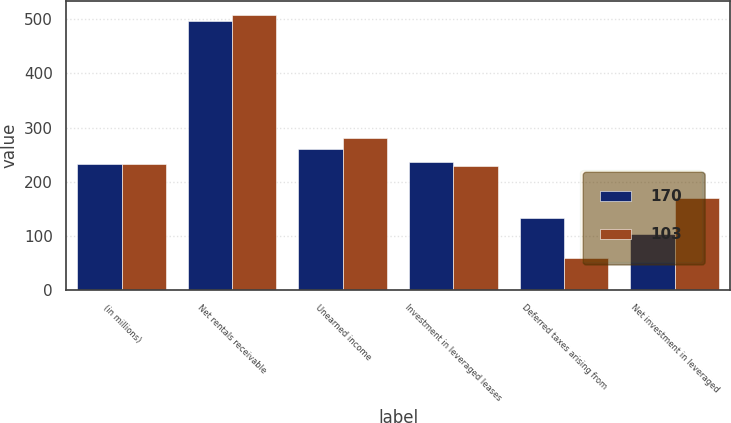Convert chart. <chart><loc_0><loc_0><loc_500><loc_500><stacked_bar_chart><ecel><fcel>(in millions)<fcel>Net rentals receivable<fcel>Unearned income<fcel>Investment in leveraged leases<fcel>Deferred taxes arising from<fcel>Net investment in leveraged<nl><fcel>170<fcel>232.5<fcel>497<fcel>261<fcel>236<fcel>133<fcel>103<nl><fcel>103<fcel>232.5<fcel>509<fcel>280<fcel>229<fcel>59<fcel>170<nl></chart> 